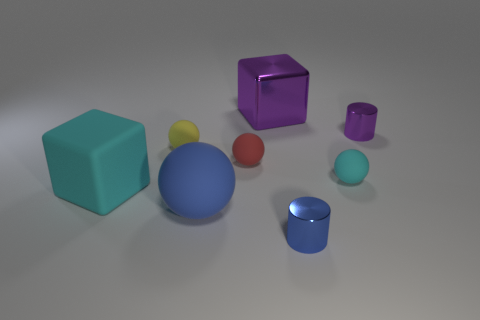Add 2 big purple matte things. How many objects exist? 10 Subtract all blocks. How many objects are left? 6 Subtract 0 purple balls. How many objects are left? 8 Subtract all gray metallic things. Subtract all blue objects. How many objects are left? 6 Add 7 big things. How many big things are left? 10 Add 4 big metallic cubes. How many big metallic cubes exist? 5 